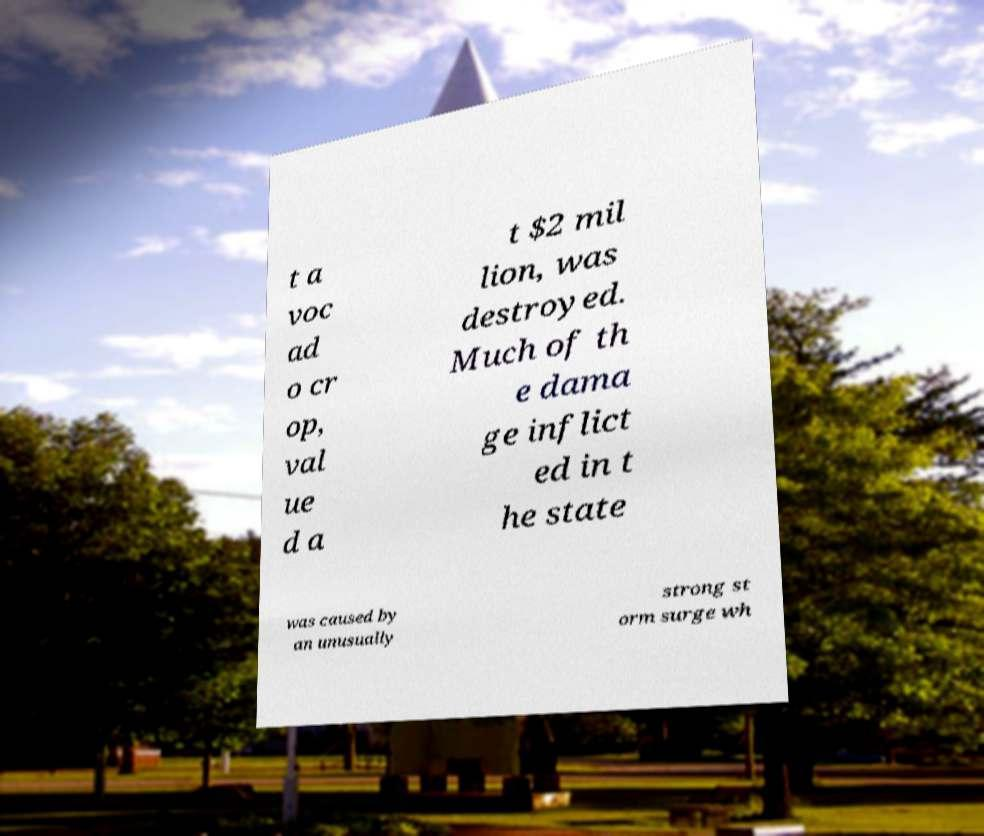Please read and relay the text visible in this image. What does it say? t a voc ad o cr op, val ue d a t $2 mil lion, was destroyed. Much of th e dama ge inflict ed in t he state was caused by an unusually strong st orm surge wh 